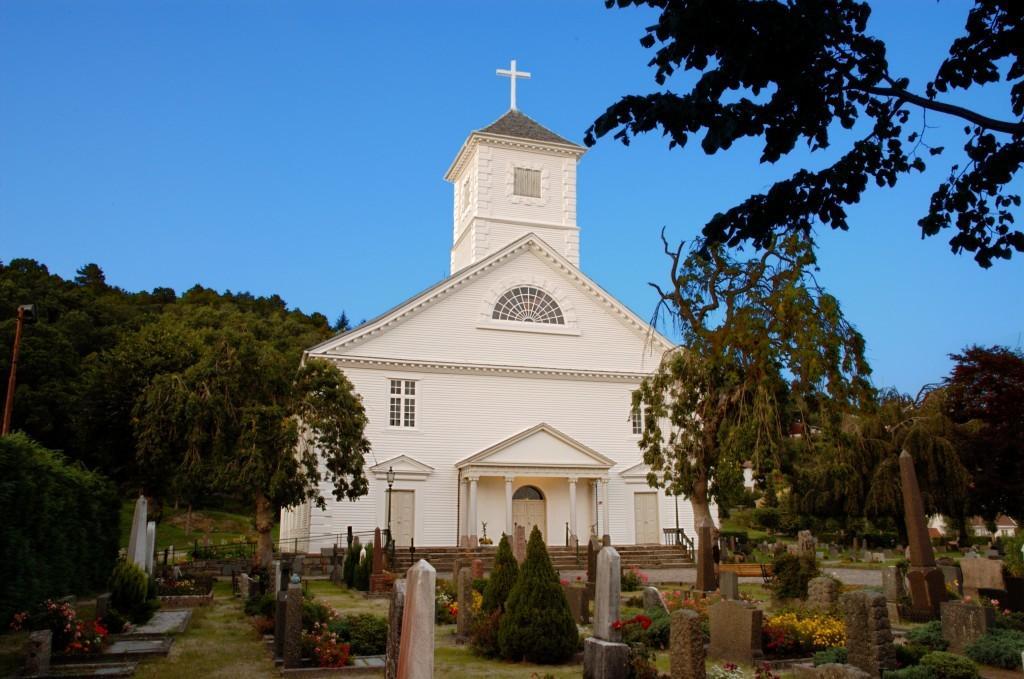How would you summarize this image in a sentence or two? This is the church building with doors and windows. I can see a holy cross symbol at the top of the building. These are the trees. I can see small bushes with flowers. This looks like a graveyard. These are the stairs. 